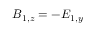<formula> <loc_0><loc_0><loc_500><loc_500>B _ { 1 , z } = - E _ { 1 , y }</formula> 